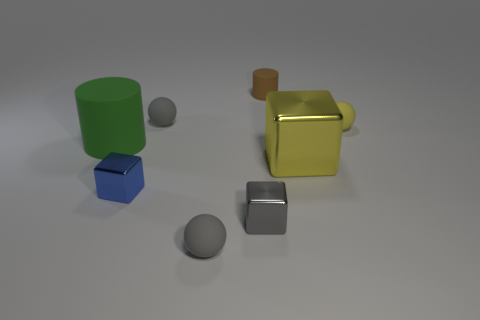Subtract all green cylinders. Subtract all green blocks. How many cylinders are left? 1 Add 1 large green objects. How many objects exist? 9 Subtract all cylinders. How many objects are left? 6 Subtract 0 brown cubes. How many objects are left? 8 Subtract all balls. Subtract all large yellow metal cubes. How many objects are left? 4 Add 1 tiny gray matte spheres. How many tiny gray matte spheres are left? 3 Add 5 large matte cylinders. How many large matte cylinders exist? 6 